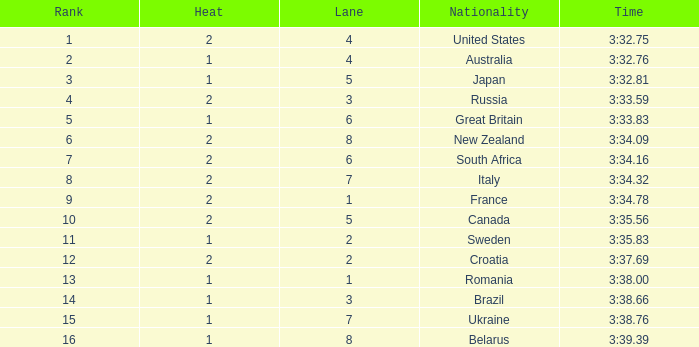Can you tell me the Rank that has the Lane of 6, and the Heat of 2? 7.0. 